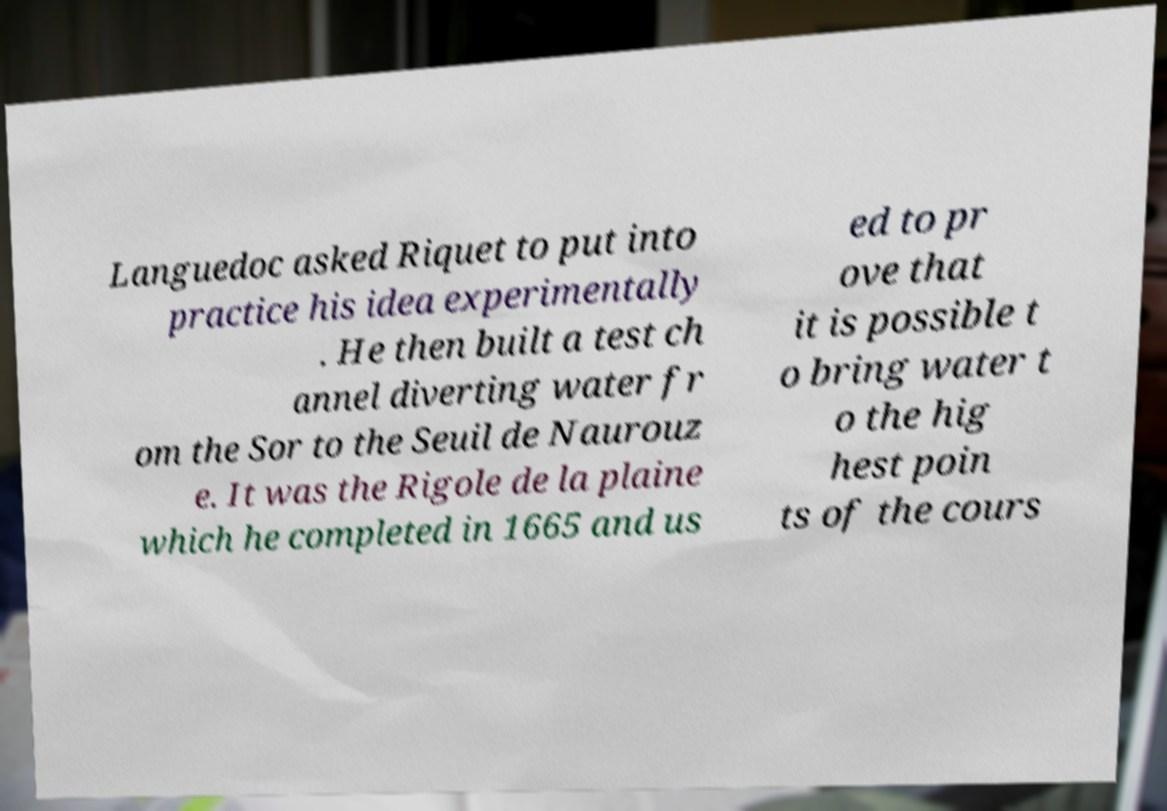Could you assist in decoding the text presented in this image and type it out clearly? Languedoc asked Riquet to put into practice his idea experimentally . He then built a test ch annel diverting water fr om the Sor to the Seuil de Naurouz e. It was the Rigole de la plaine which he completed in 1665 and us ed to pr ove that it is possible t o bring water t o the hig hest poin ts of the cours 